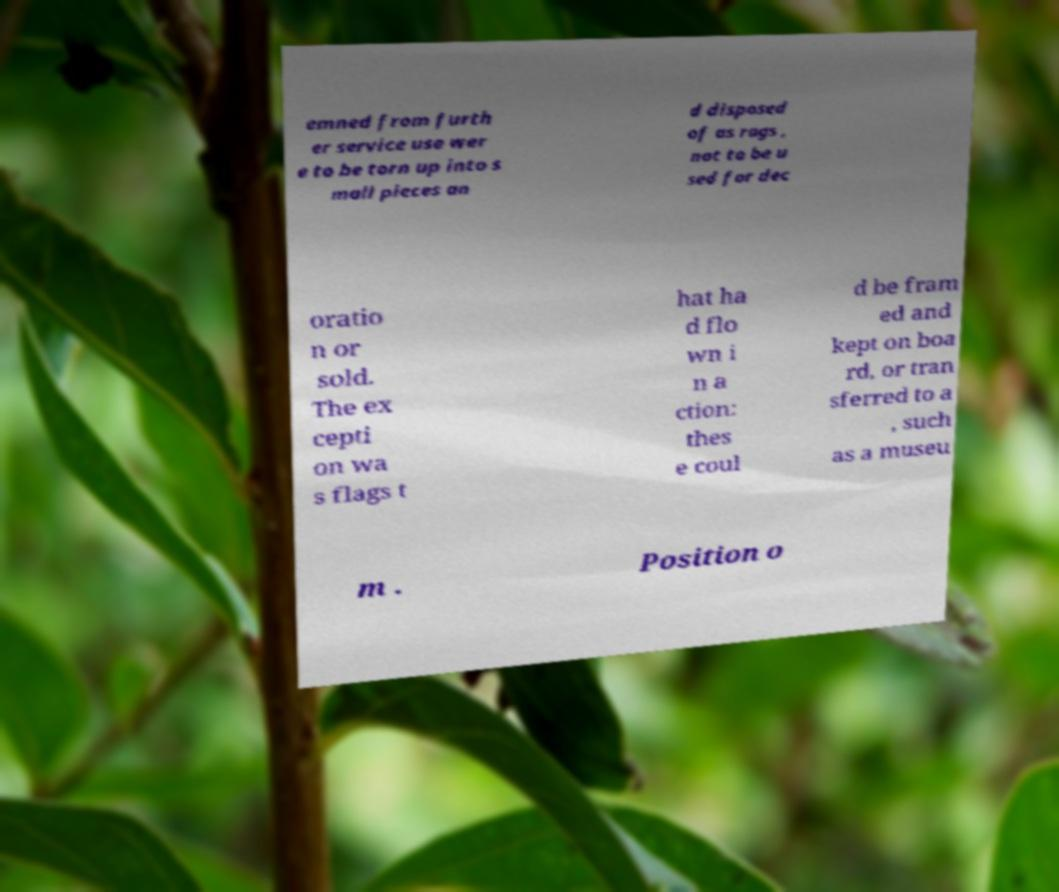Please identify and transcribe the text found in this image. emned from furth er service use wer e to be torn up into s mall pieces an d disposed of as rags , not to be u sed for dec oratio n or sold. The ex cepti on wa s flags t hat ha d flo wn i n a ction: thes e coul d be fram ed and kept on boa rd, or tran sferred to a , such as a museu m . Position o 